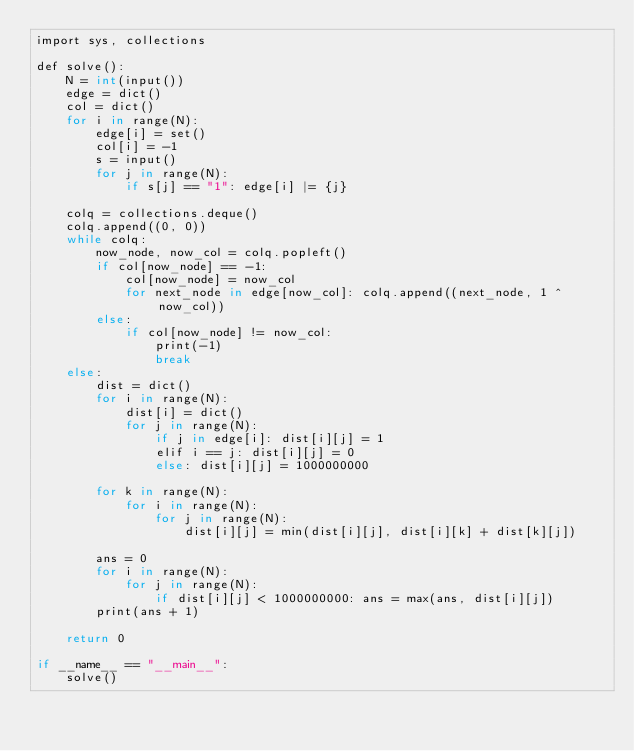<code> <loc_0><loc_0><loc_500><loc_500><_C#_>import sys, collections
 
def solve():
    N = int(input())
    edge = dict()
    col = dict()
    for i in range(N): 
        edge[i] = set()
        col[i] = -1
        s = input()
        for j in range(N):
            if s[j] == "1": edge[i] |= {j}
 
    colq = collections.deque()
    colq.append((0, 0))
    while colq:
        now_node, now_col = colq.popleft()
        if col[now_node] == -1:
            col[now_node] = now_col
            for next_node in edge[now_col]: colq.append((next_node, 1 ^ now_col))
        else:
            if col[now_node] != now_col: 
                print(-1)
                break
    else:
        dist = dict()
        for i in range(N):
            dist[i] = dict()
            for j in range(N):
                if j in edge[i]: dist[i][j] = 1
                elif i == j: dist[i][j] = 0
                else: dist[i][j] = 1000000000
 
        for k in range(N):
            for i in range(N):
                for j in range(N):
                    dist[i][j] = min(dist[i][j], dist[i][k] + dist[k][j])
 
        ans = 0
        for i in range(N):
            for j in range(N):
                if dist[i][j] < 1000000000: ans = max(ans, dist[i][j])
        print(ans + 1)
 
    return 0
 
if __name__ == "__main__":
    solve()</code> 